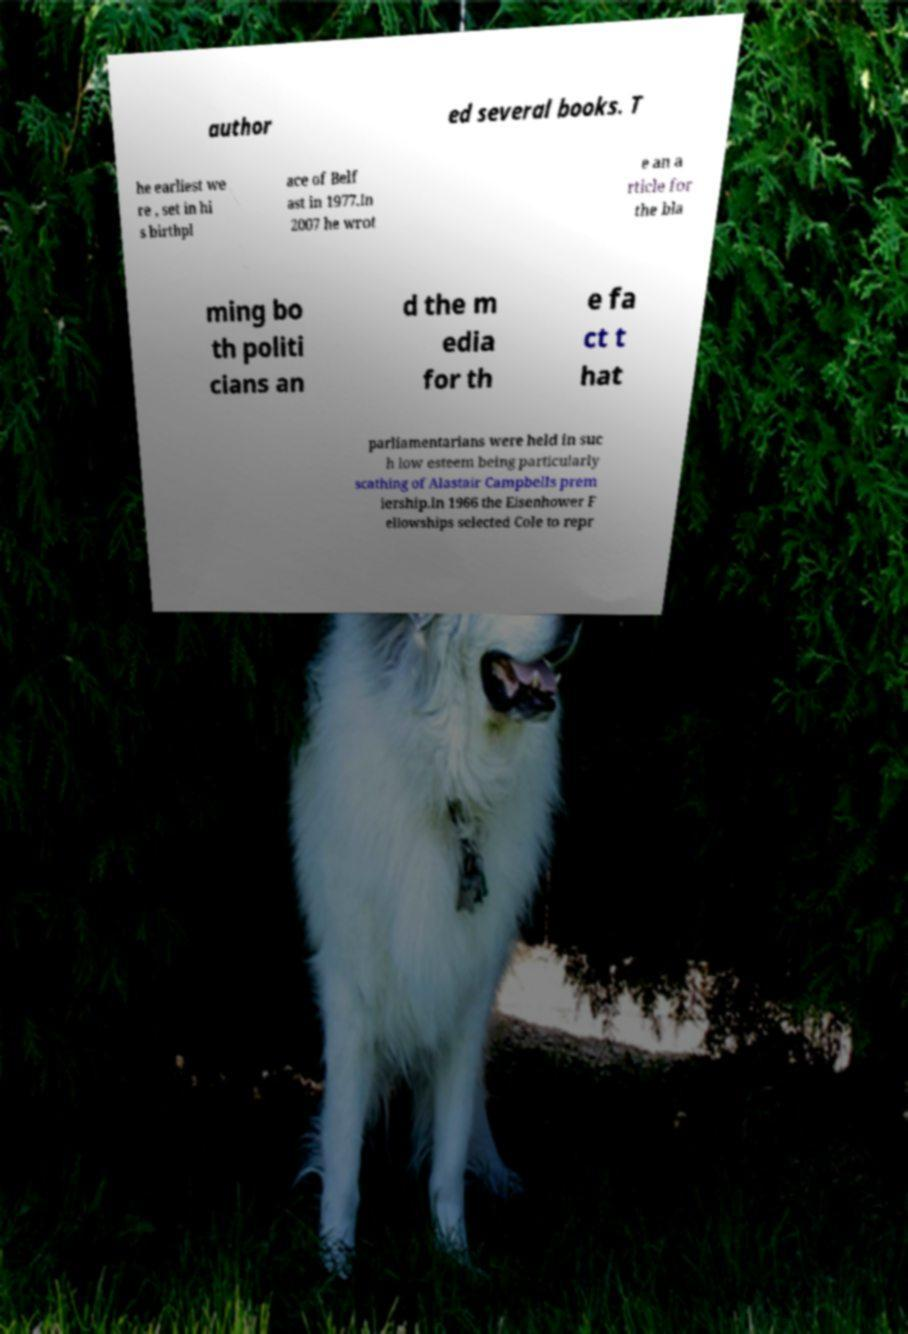What messages or text are displayed in this image? I need them in a readable, typed format. author ed several books. T he earliest we re , set in hi s birthpl ace of Belf ast in 1977.In 2007 he wrot e an a rticle for the bla ming bo th politi cians an d the m edia for th e fa ct t hat parliamentarians were held in suc h low esteem being particularly scathing of Alastair Campbells prem iership.In 1966 the Eisenhower F ellowships selected Cole to repr 